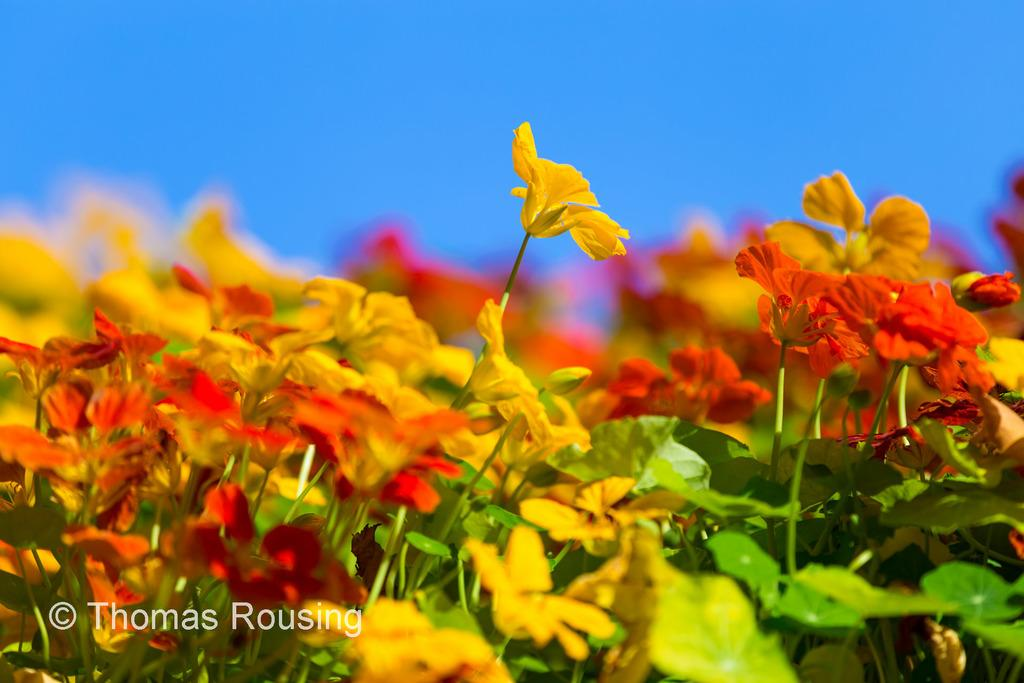What type of plants are present in the image? There are plants with flowers in the image. What colors are the flowers on the plants? The flowers are in yellow and red colors. What is visible at the top of the image? The sky is visible at the top of the image. Where is the text located in the image? The text is at the bottom left of the image. Can you tell me how many horses are grazing in the image? There are no horses present in the image; it features plants with flowers and text. What type of crib is visible in the image? There is no crib present in the image. 